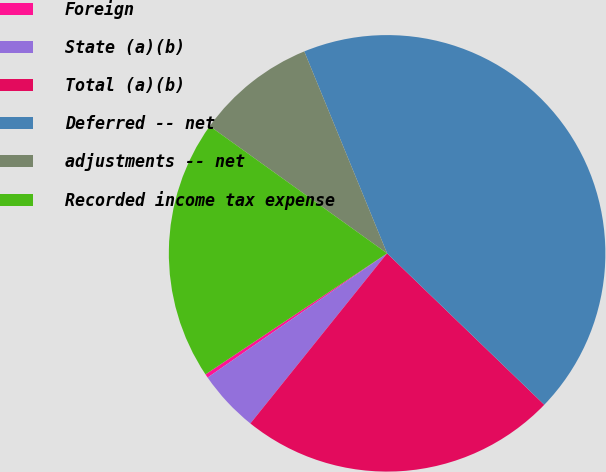Convert chart to OTSL. <chart><loc_0><loc_0><loc_500><loc_500><pie_chart><fcel>Foreign<fcel>State (a)(b)<fcel>Total (a)(b)<fcel>Deferred -- net<fcel>adjustments -- net<fcel>Recorded income tax expense<nl><fcel>0.28%<fcel>4.59%<fcel>23.57%<fcel>43.4%<fcel>8.9%<fcel>19.26%<nl></chart> 